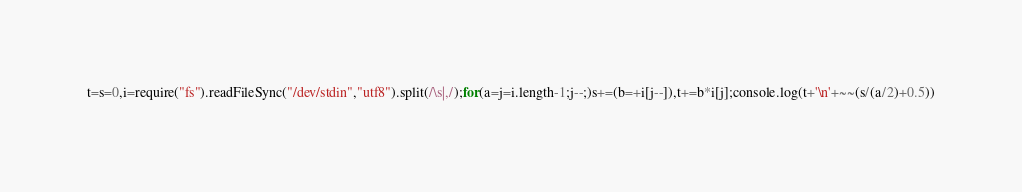Convert code to text. <code><loc_0><loc_0><loc_500><loc_500><_JavaScript_>t=s=0,i=require("fs").readFileSync("/dev/stdin","utf8").split(/\s|,/);for(a=j=i.length-1;j--;)s+=(b=+i[j--]),t+=b*i[j];console.log(t+'\n'+~~(s/(a/2)+0.5))</code> 